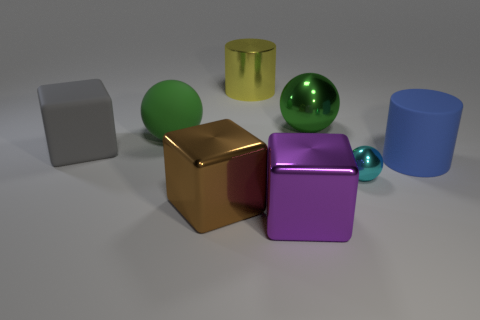Is there any other thing that is the same size as the cyan metallic sphere?
Your answer should be compact. No. How big is the cylinder on the left side of the big matte object in front of the large cube behind the blue cylinder?
Make the answer very short. Large. How many things are either balls that are right of the big yellow shiny cylinder or large metallic blocks that are on the left side of the large yellow shiny cylinder?
Keep it short and to the point. 3. There is a green matte thing; what shape is it?
Your response must be concise. Sphere. What number of other things are there of the same material as the gray cube
Ensure brevity in your answer.  2. What size is the other metallic thing that is the same shape as the small shiny thing?
Make the answer very short. Large. There is a large thing on the right side of the metal sphere that is in front of the matte thing on the right side of the small shiny ball; what is it made of?
Ensure brevity in your answer.  Rubber. Are any large rubber cylinders visible?
Keep it short and to the point. Yes. There is a large matte block; does it have the same color as the metallic ball behind the small cyan metal object?
Your response must be concise. No. The small sphere is what color?
Offer a very short reply. Cyan. 